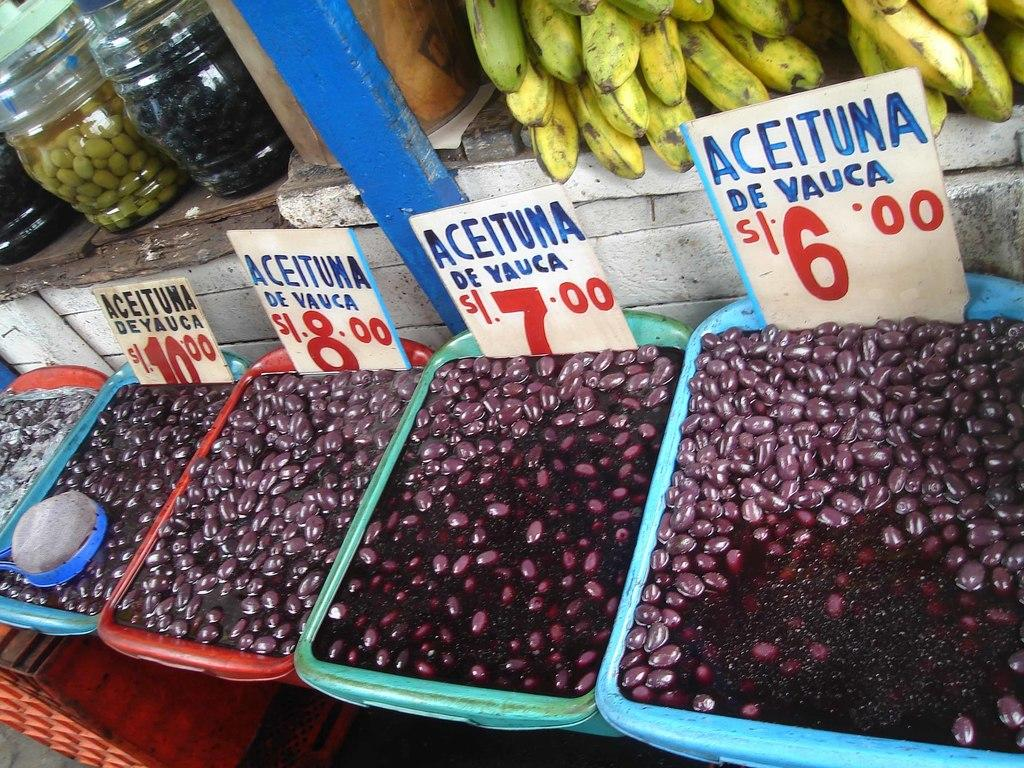What type of food can be seen in the image? There is food in the image, but the specific type is not mentioned. What are the boards in the trays used for? The purpose of the boards in the trays is not mentioned in the facts. What objects are visible at the top of the image? Jars and bananas are visible at the top of the image. Where is the map located in the image? There is no map present in the image. How many drops of water can be seen falling from the hydrant in the image? There is no hydrant present in the image. 